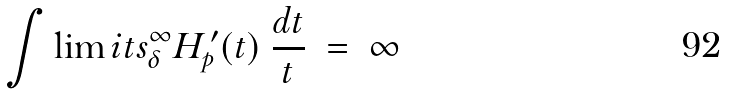Convert formula to latex. <formula><loc_0><loc_0><loc_500><loc_500>\int \lim i t s _ { \delta } ^ { \infty } H ^ { \, \prime } _ { p } ( t ) \ \frac { d t } { t } \ = \ \infty</formula> 